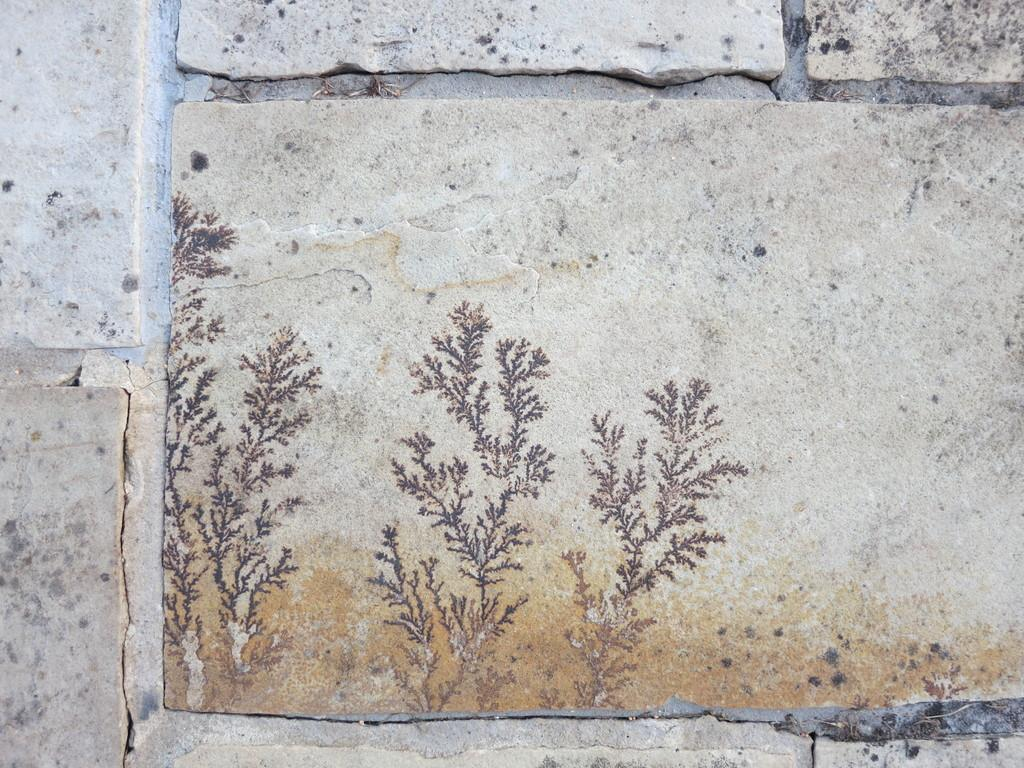What type of structure is present in the image? There is a stone wall in the image. What is on the stone wall? There is a painting on the stone wall. Where is the seat located in the image? There is no seat present in the image. What type of boot is depicted in the painting on the stone wall? The painting on the stone wall does not depict a boot; it is not mentioned in the provided facts. 